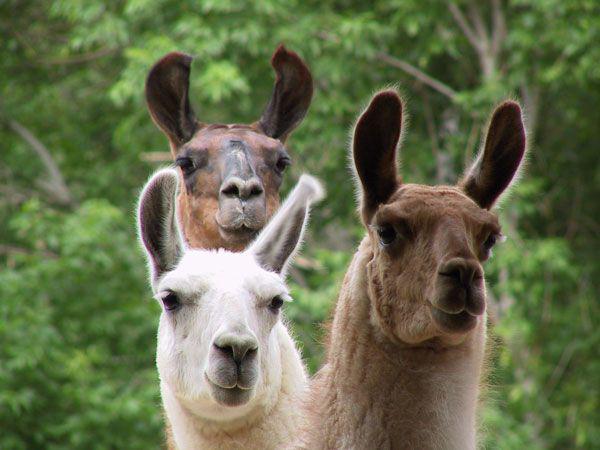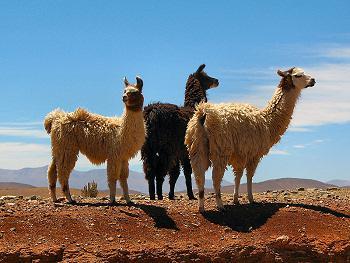The first image is the image on the left, the second image is the image on the right. Considering the images on both sides, is "The left and right image contains the same number of Llamas." valid? Answer yes or no. Yes. The first image is the image on the left, the second image is the image on the right. Assess this claim about the two images: "One image shows three forward-facing llamas with non-shaggy faces, and the other image contains three llamas with shaggy wool.". Correct or not? Answer yes or no. Yes. 